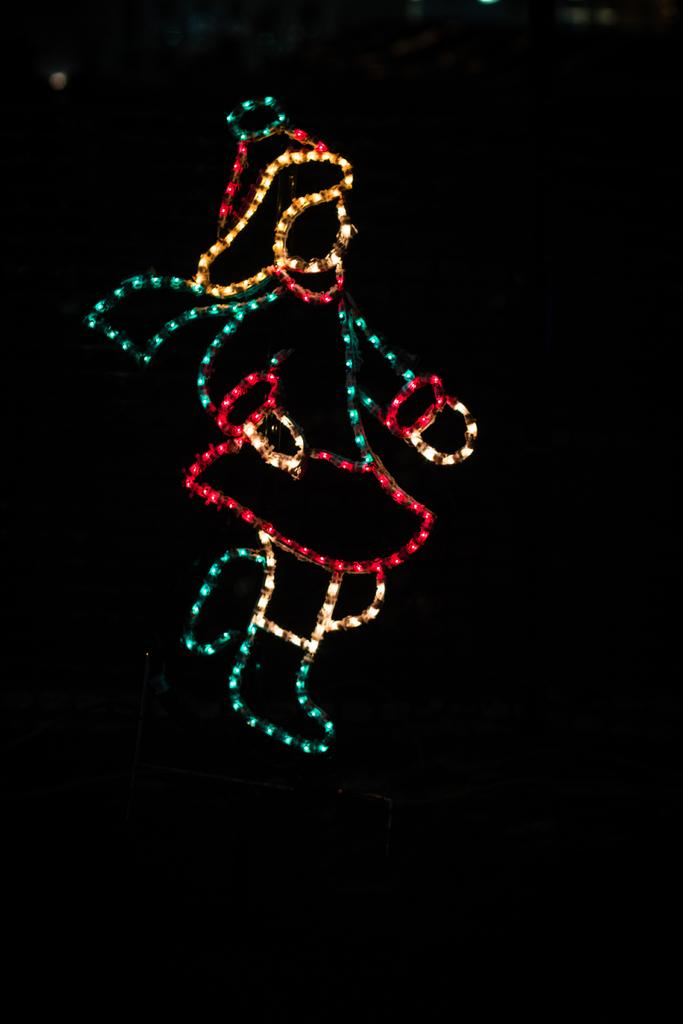What can be seen in the image that provides illumination? There are lights in the image. How would you describe the overall brightness of the image? The background of the image is dark. What type of protest is taking place in the image? There is no protest present in the image; it only features lights and a dark background. What subject is being taught in the image? There is no teaching or educational context present in the image. 